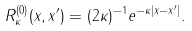Convert formula to latex. <formula><loc_0><loc_0><loc_500><loc_500>R _ { \kappa } ^ { ( 0 ) } ( x , x ^ { \prime } ) = ( 2 \kappa ) ^ { - 1 } e ^ { - \kappa | x - x ^ { \prime } | } .</formula> 